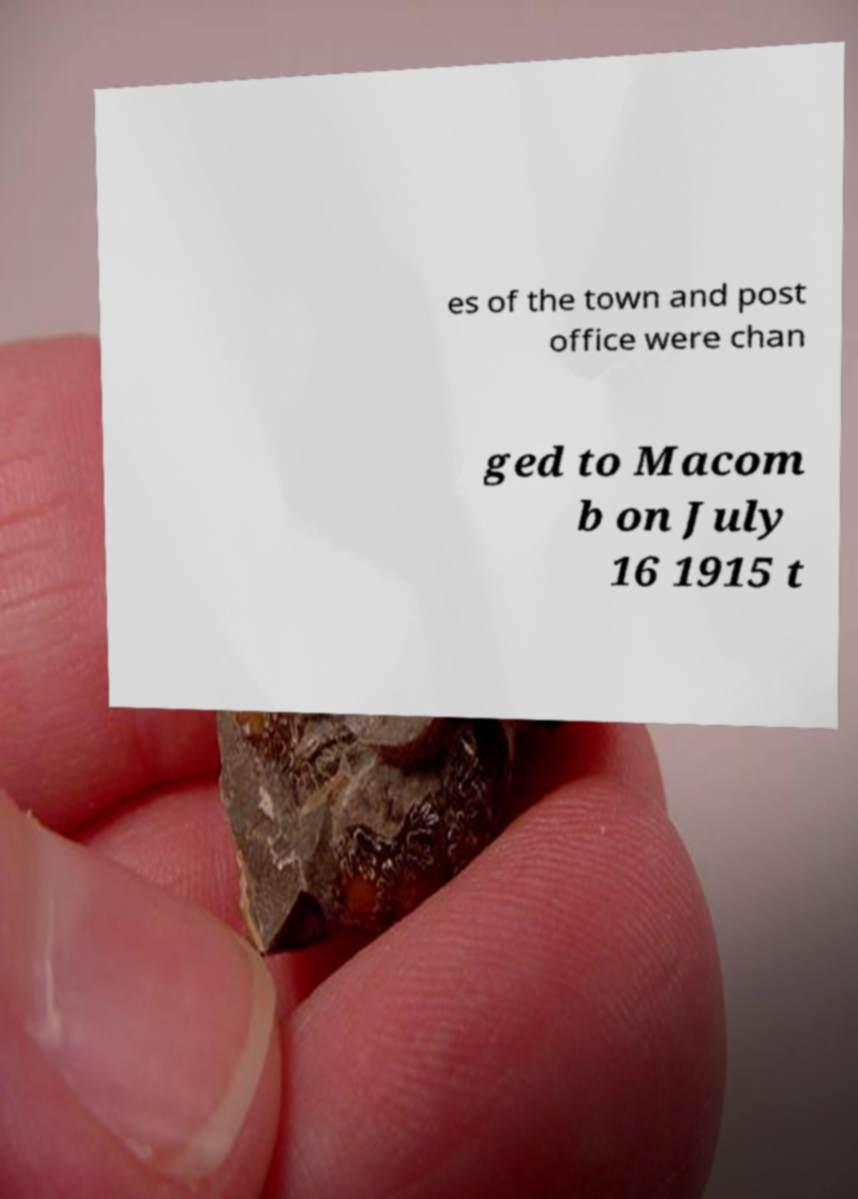Can you read and provide the text displayed in the image?This photo seems to have some interesting text. Can you extract and type it out for me? es of the town and post office were chan ged to Macom b on July 16 1915 t 